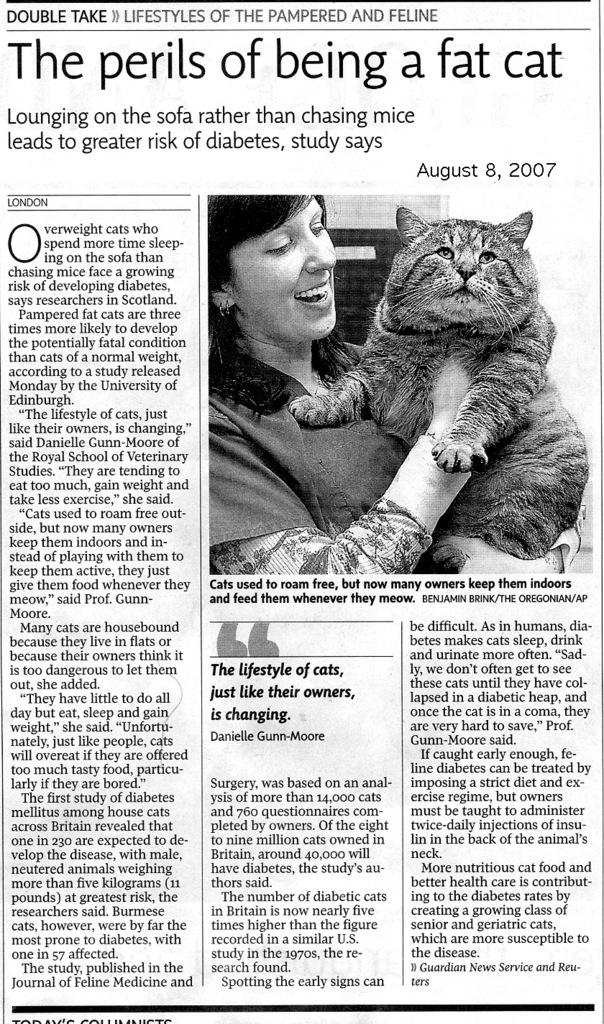What is the main subject of the image? The main subject of the image is an article in a newspaper. What can be found on the article? The article has text on it. What else is present in the image besides the newspaper article? There is a picture of a woman in the image. What is the woman doing in the picture? The woman is holding a cat in her arms. Where is the station located in the image? There is no station present in the image. Can you see any stamps on the cat in the image? There are no stamps visible on the cat in the image. 